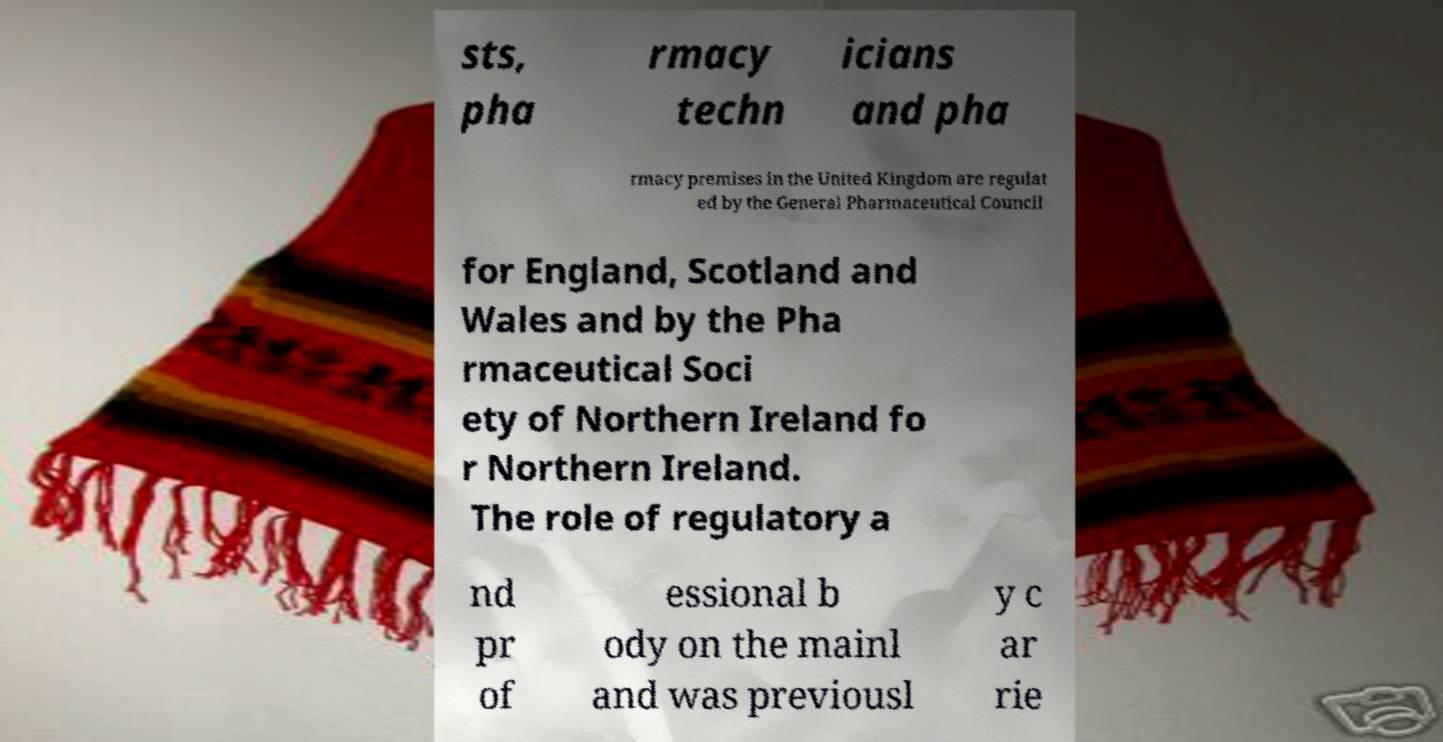Can you read and provide the text displayed in the image?This photo seems to have some interesting text. Can you extract and type it out for me? sts, pha rmacy techn icians and pha rmacy premises in the United Kingdom are regulat ed by the General Pharmaceutical Council for England, Scotland and Wales and by the Pha rmaceutical Soci ety of Northern Ireland fo r Northern Ireland. The role of regulatory a nd pr of essional b ody on the mainl and was previousl y c ar rie 